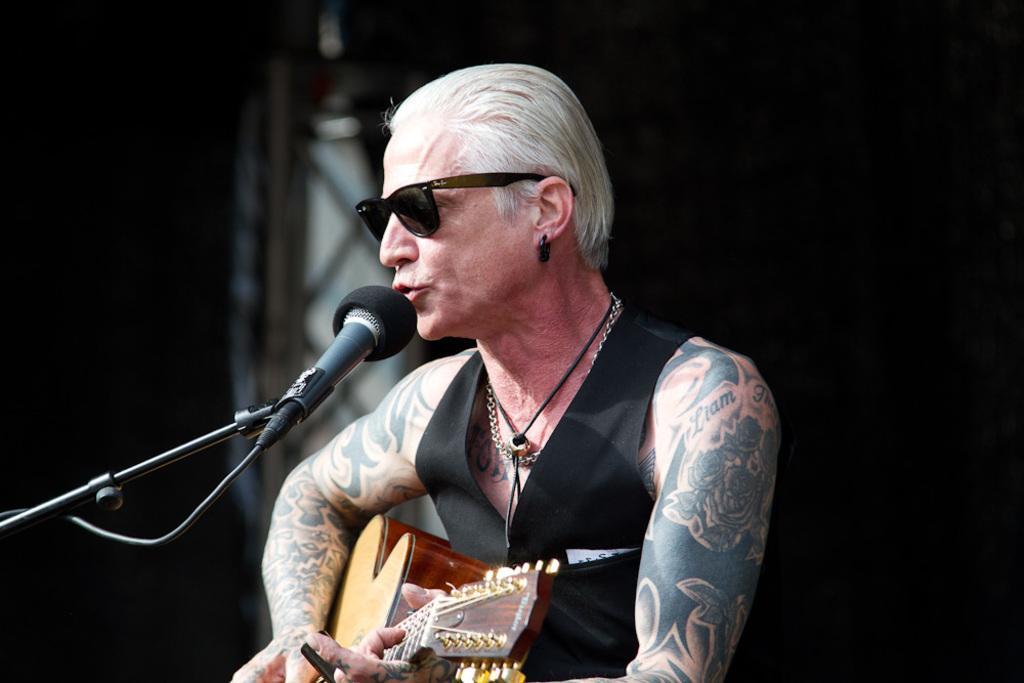Could you give a brief overview of what you see in this image? This picture shows a man playing a guitar and singing with the help of a microphone 